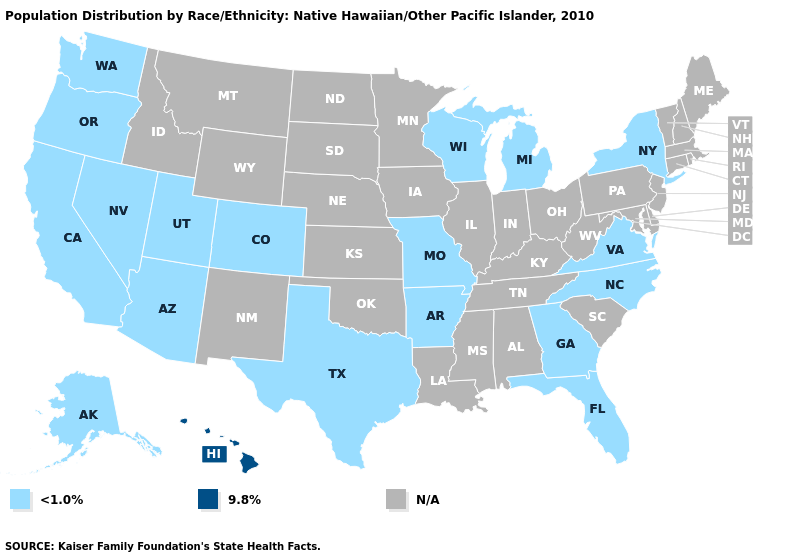What is the highest value in the West ?
Quick response, please. 9.8%. Name the states that have a value in the range 9.8%?
Answer briefly. Hawaii. Name the states that have a value in the range N/A?
Short answer required. Alabama, Connecticut, Delaware, Idaho, Illinois, Indiana, Iowa, Kansas, Kentucky, Louisiana, Maine, Maryland, Massachusetts, Minnesota, Mississippi, Montana, Nebraska, New Hampshire, New Jersey, New Mexico, North Dakota, Ohio, Oklahoma, Pennsylvania, Rhode Island, South Carolina, South Dakota, Tennessee, Vermont, West Virginia, Wyoming. What is the value of Iowa?
Keep it brief. N/A. Is the legend a continuous bar?
Quick response, please. No. Name the states that have a value in the range 9.8%?
Answer briefly. Hawaii. What is the lowest value in the USA?
Concise answer only. <1.0%. What is the lowest value in states that border Vermont?
Write a very short answer. <1.0%. What is the highest value in the West ?
Concise answer only. 9.8%. Does the map have missing data?
Answer briefly. Yes. What is the value of California?
Keep it brief. <1.0%. Name the states that have a value in the range 9.8%?
Give a very brief answer. Hawaii. What is the value of Texas?
Answer briefly. <1.0%. What is the lowest value in the USA?
Quick response, please. <1.0%. Does Washington have the highest value in the USA?
Quick response, please. No. 